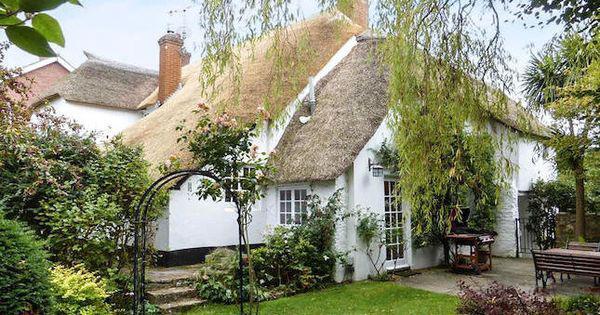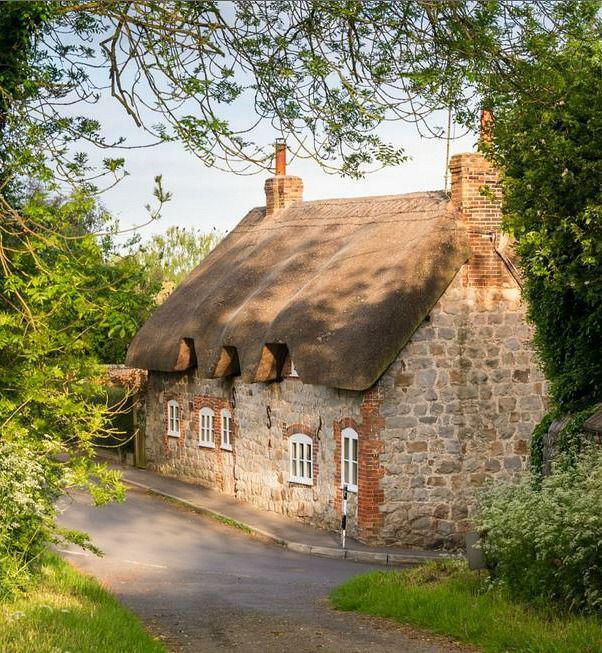The first image is the image on the left, the second image is the image on the right. Given the left and right images, does the statement "A house has a red door." hold true? Answer yes or no. No. 